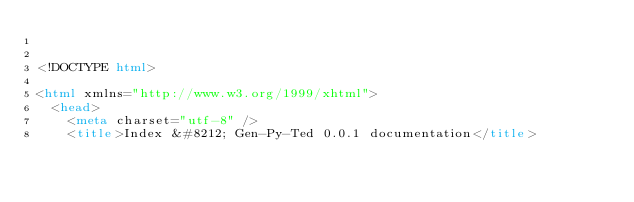<code> <loc_0><loc_0><loc_500><loc_500><_HTML_>

<!DOCTYPE html>

<html xmlns="http://www.w3.org/1999/xhtml">
  <head>
    <meta charset="utf-8" />
    <title>Index &#8212; Gen-Py-Ted 0.0.1 documentation</title></code> 